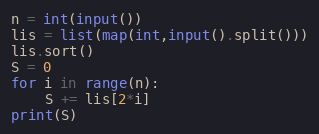Convert code to text. <code><loc_0><loc_0><loc_500><loc_500><_Python_>n = int(input())
lis = list(map(int,input().split()))
lis.sort()
S = 0
for i in range(n):
    S += lis[2*i]
print(S)
</code> 